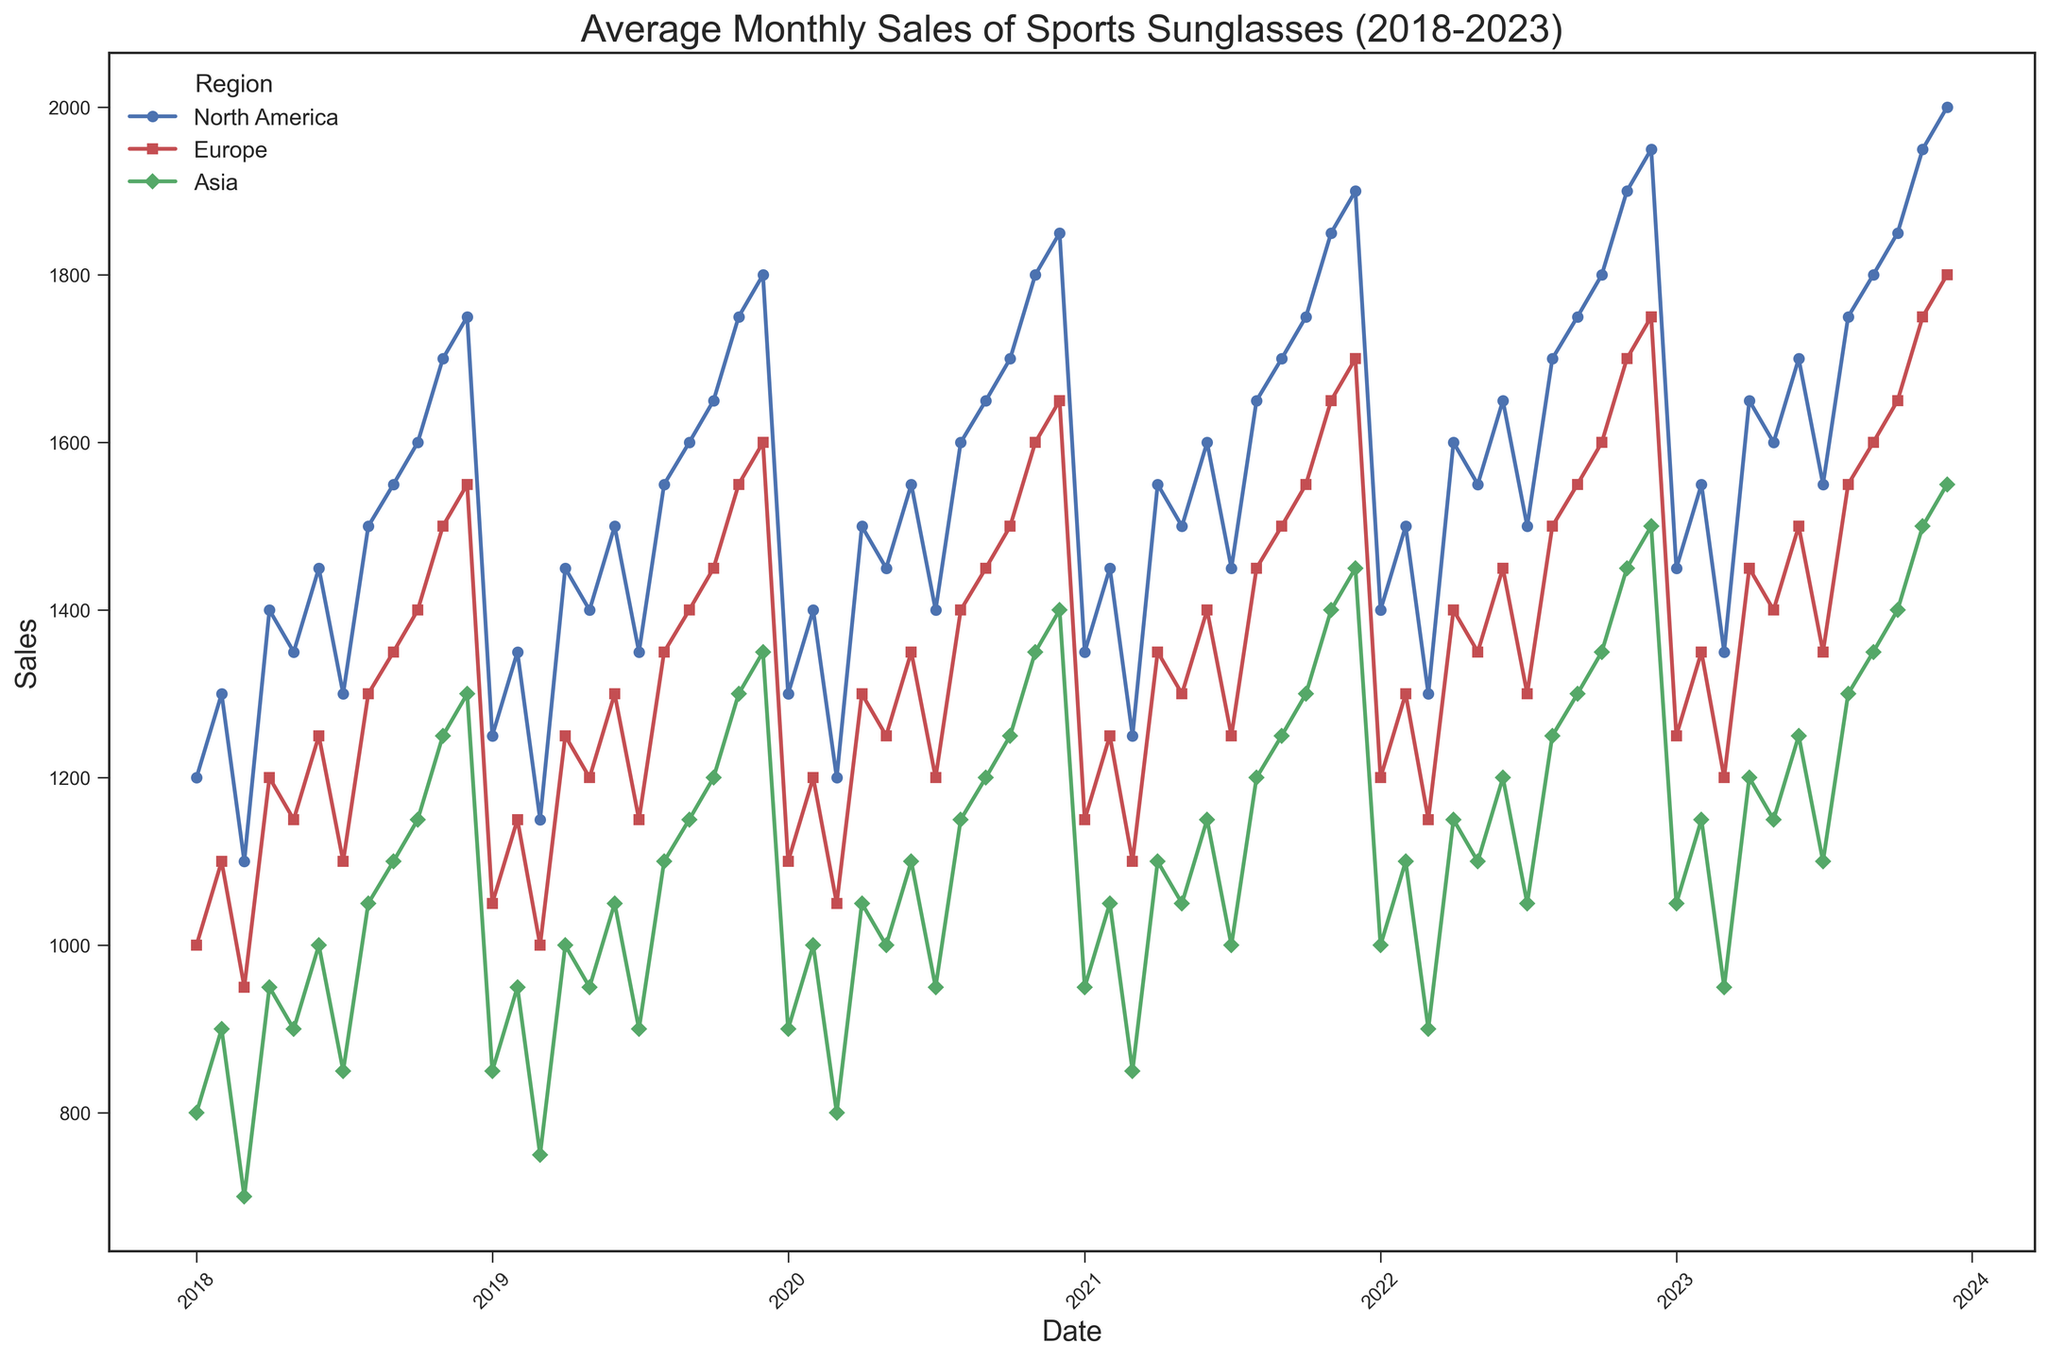What was the highest monthly sales figure in North America in the last five years? By examining the North American sales trend, the highest point on the line can be identified, which is around December 2023. The sales figure at this peak is 2000.
Answer: 2000 How do the average monthly sales in Europe in 2019 compare to Asia in the same year? To find the average sales in Europe and Asia for 2019, we sum the monthly sales for each region separately and divide each by 12 (the number of months). For Europe, the sum is 16800 (1050 + 1150 + 1000 + 1250 + 1200 + 1300 + 1150 + 1350 + 1400 + 1450 + 1550 + 1600) and the average is 16800/12 = 1400. For Asia, the sum is 13800 (850 + 950 + 750 + 1000 + 950 + 1050 + 900 + 1100 + 1150 + 1200 + 1300 + 1350) and the average is 13800/12 = 1150.
Answer: Europe: 1400, Asia: 1150 Which region had the most consistent sales pattern throughout the last five years? A consistent sales pattern would exhibit relatively stable or smooth trends without significant fluctuations. Comparing the lines for each region, Europe shows the most steady increase with fewer spikes and dips in sales over the years.
Answer: Europe By how much did the sales in Asia increase from January 2018 to December 2023? To find the increase, subtract the sales figure in January 2018 from the sales figure in December 2023 for Asia. The sales in January 2018 were 800, and in December 2023 they were 1550. Therefore, the increase is 1550 - 800 = 750.
Answer: 750 In which year did Europe experience the largest growth in monthly sales, and what was the percentage increase? To determine the largest growth, we need to find the year with the highest difference between January and December sales. Europe had January and December sales in 2021 of 1150 and 1700 respectively. The increase is 1700 - 1150 = 550. To find the percentage increase: (550 / 1150) * 100 ≈ 47.8%.
Answer: 2021, 47.8% Which two regions had the closest sales figures at the end of 2023, and what were those figures? At the end of 2023, observe the sales figures in December for each region: North America (2000), Europe (1800), and Asia (1550). The closest two figures are Europe’s 1800 and Asia’s 1550. The difference is 1800 - 1550 = 250.
Answer: Europe and Asia, Europe: 1800, Asia: 1550 How did the sales trend change after June 2020 in North America? After June 2020 in North America, the line shows a marked upward trajectory, indicating a significant increase in monthly sales figures from around 1500 in June to 1850 by December 2020.
Answer: Uptrend Which region had the highest variability in sales over the last five years, and what indicates this variability? Variability in sales can be indicated by the number of peaks and troughs in the line graph. North America shows the most variability with visible frequent ups and downs in the sales figures throughout the five years.
Answer: North America 